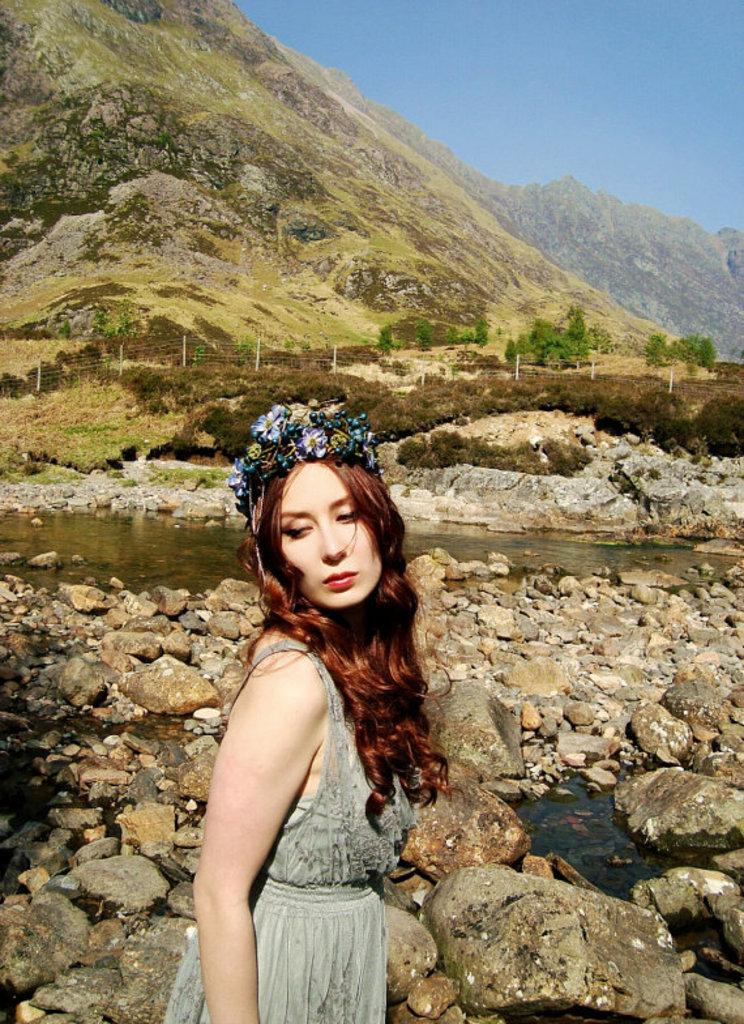What is the main subject of the image? There is a woman standing in the image. Can you describe what the woman is wearing? The woman is wearing clothes and a flower crown. What type of natural elements can be seen in the image? There are stones, water, grass, a plant, and mountains visible in the image. What is the color of the sky in the image? The sky is pale blue in the image. What type of dinosaurs can be seen grazing on the grass in the image? There are no dinosaurs present in the image; it features a woman standing in a natural environment. Can you tell me how many members are on the committee in the image? There is no committee present in the image, as it focuses on a woman standing in a natural setting. 